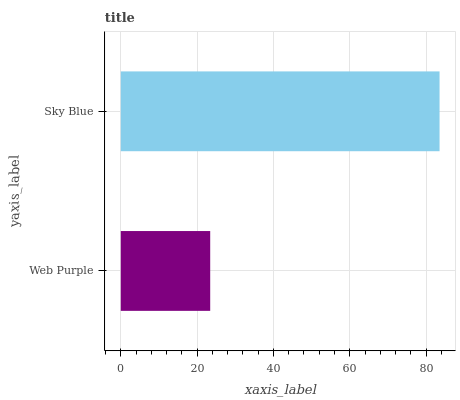Is Web Purple the minimum?
Answer yes or no. Yes. Is Sky Blue the maximum?
Answer yes or no. Yes. Is Sky Blue the minimum?
Answer yes or no. No. Is Sky Blue greater than Web Purple?
Answer yes or no. Yes. Is Web Purple less than Sky Blue?
Answer yes or no. Yes. Is Web Purple greater than Sky Blue?
Answer yes or no. No. Is Sky Blue less than Web Purple?
Answer yes or no. No. Is Sky Blue the high median?
Answer yes or no. Yes. Is Web Purple the low median?
Answer yes or no. Yes. Is Web Purple the high median?
Answer yes or no. No. Is Sky Blue the low median?
Answer yes or no. No. 